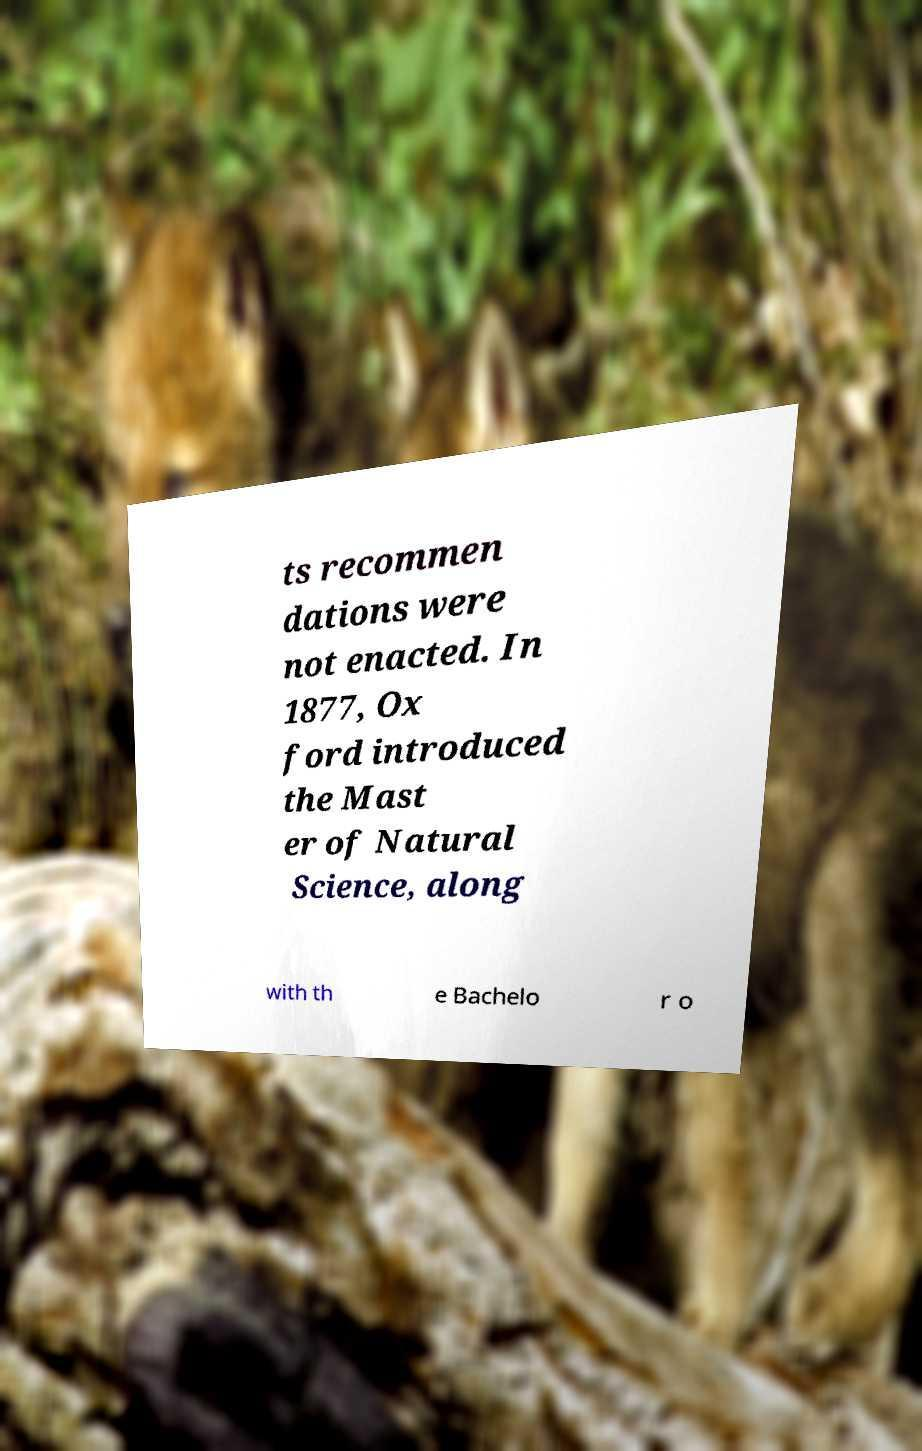Could you extract and type out the text from this image? ts recommen dations were not enacted. In 1877, Ox ford introduced the Mast er of Natural Science, along with th e Bachelo r o 